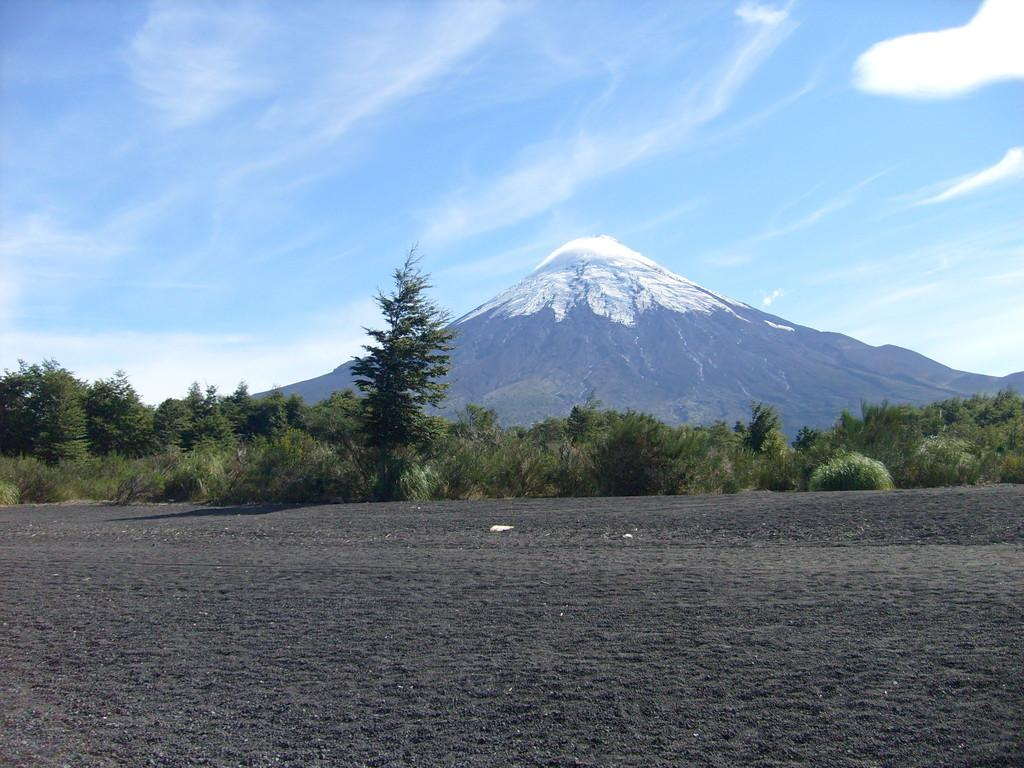What type of vegetation can be seen in the image? There are trees and plants in the image. What type of terrain is visible in the image? There are hills visible in the image. What is present at the bottom of the image? Soil is present at the bottom of the image. What is visible at the top of the image? The sky is visible at the top of the image. What can be seen in the sky? Clouds are present in the sky. How does the tax rate compare between the trees and plants in the image? There is no information about tax rates in the image, as it features natural elements like trees, plants, hills, soil, and sky. 